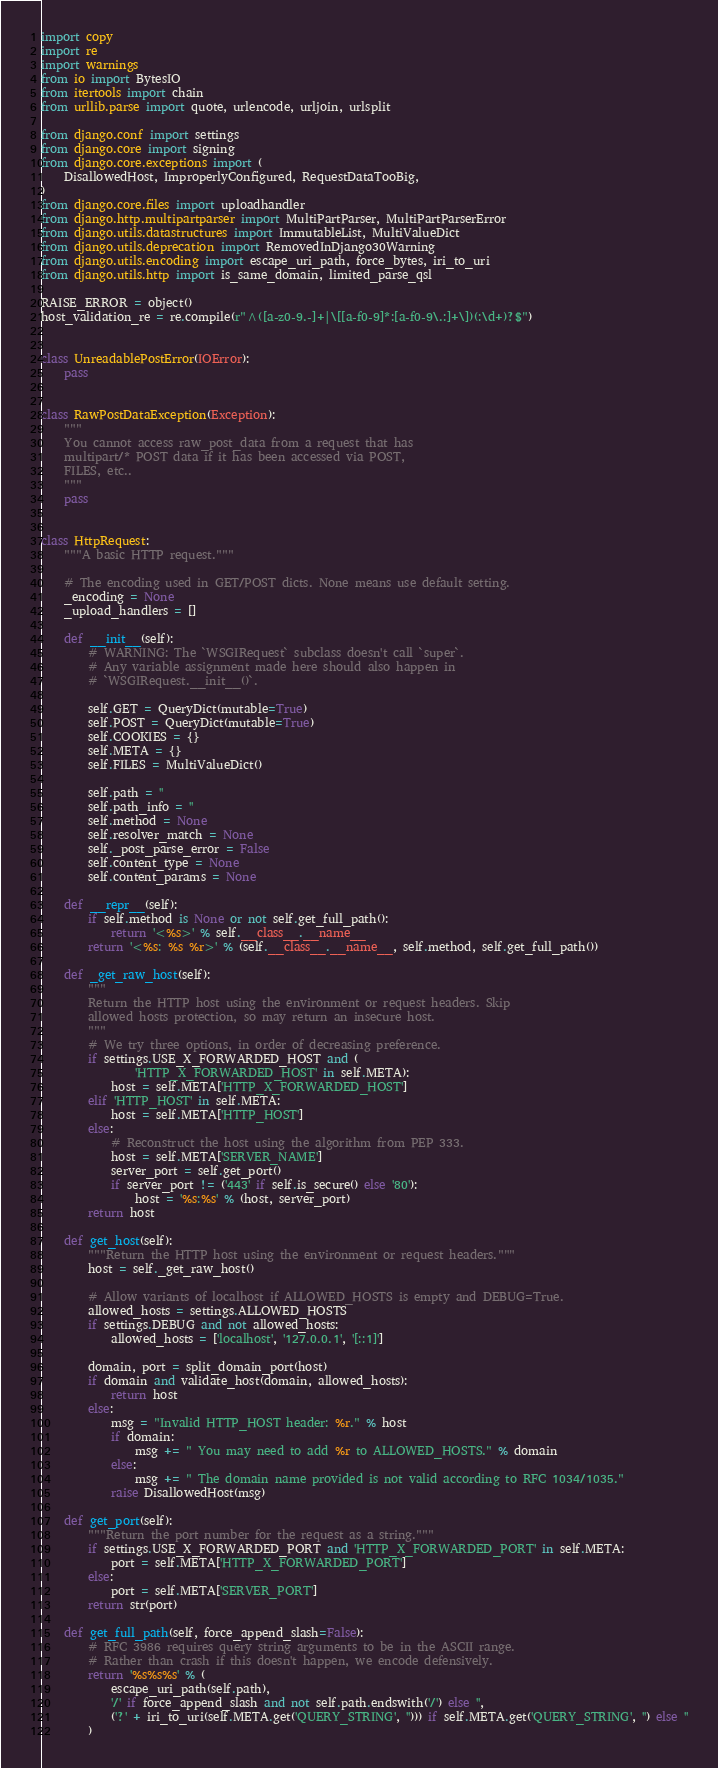<code> <loc_0><loc_0><loc_500><loc_500><_Python_>import copy
import re
import warnings
from io import BytesIO
from itertools import chain
from urllib.parse import quote, urlencode, urljoin, urlsplit

from django.conf import settings
from django.core import signing
from django.core.exceptions import (
    DisallowedHost, ImproperlyConfigured, RequestDataTooBig,
)
from django.core.files import uploadhandler
from django.http.multipartparser import MultiPartParser, MultiPartParserError
from django.utils.datastructures import ImmutableList, MultiValueDict
from django.utils.deprecation import RemovedInDjango30Warning
from django.utils.encoding import escape_uri_path, force_bytes, iri_to_uri
from django.utils.http import is_same_domain, limited_parse_qsl

RAISE_ERROR = object()
host_validation_re = re.compile(r"^([a-z0-9.-]+|\[[a-f0-9]*:[a-f0-9\.:]+\])(:\d+)?$")


class UnreadablePostError(IOError):
    pass


class RawPostDataException(Exception):
    """
    You cannot access raw_post_data from a request that has
    multipart/* POST data if it has been accessed via POST,
    FILES, etc..
    """
    pass


class HttpRequest:
    """A basic HTTP request."""

    # The encoding used in GET/POST dicts. None means use default setting.
    _encoding = None
    _upload_handlers = []

    def __init__(self):
        # WARNING: The `WSGIRequest` subclass doesn't call `super`.
        # Any variable assignment made here should also happen in
        # `WSGIRequest.__init__()`.

        self.GET = QueryDict(mutable=True)
        self.POST = QueryDict(mutable=True)
        self.COOKIES = {}
        self.META = {}
        self.FILES = MultiValueDict()

        self.path = ''
        self.path_info = ''
        self.method = None
        self.resolver_match = None
        self._post_parse_error = False
        self.content_type = None
        self.content_params = None

    def __repr__(self):
        if self.method is None or not self.get_full_path():
            return '<%s>' % self.__class__.__name__
        return '<%s: %s %r>' % (self.__class__.__name__, self.method, self.get_full_path())

    def _get_raw_host(self):
        """
        Return the HTTP host using the environment or request headers. Skip
        allowed hosts protection, so may return an insecure host.
        """
        # We try three options, in order of decreasing preference.
        if settings.USE_X_FORWARDED_HOST and (
                'HTTP_X_FORWARDED_HOST' in self.META):
            host = self.META['HTTP_X_FORWARDED_HOST']
        elif 'HTTP_HOST' in self.META:
            host = self.META['HTTP_HOST']
        else:
            # Reconstruct the host using the algorithm from PEP 333.
            host = self.META['SERVER_NAME']
            server_port = self.get_port()
            if server_port != ('443' if self.is_secure() else '80'):
                host = '%s:%s' % (host, server_port)
        return host

    def get_host(self):
        """Return the HTTP host using the environment or request headers."""
        host = self._get_raw_host()

        # Allow variants of localhost if ALLOWED_HOSTS is empty and DEBUG=True.
        allowed_hosts = settings.ALLOWED_HOSTS
        if settings.DEBUG and not allowed_hosts:
            allowed_hosts = ['localhost', '127.0.0.1', '[::1]']

        domain, port = split_domain_port(host)
        if domain and validate_host(domain, allowed_hosts):
            return host
        else:
            msg = "Invalid HTTP_HOST header: %r." % host
            if domain:
                msg += " You may need to add %r to ALLOWED_HOSTS." % domain
            else:
                msg += " The domain name provided is not valid according to RFC 1034/1035."
            raise DisallowedHost(msg)

    def get_port(self):
        """Return the port number for the request as a string."""
        if settings.USE_X_FORWARDED_PORT and 'HTTP_X_FORWARDED_PORT' in self.META:
            port = self.META['HTTP_X_FORWARDED_PORT']
        else:
            port = self.META['SERVER_PORT']
        return str(port)

    def get_full_path(self, force_append_slash=False):
        # RFC 3986 requires query string arguments to be in the ASCII range.
        # Rather than crash if this doesn't happen, we encode defensively.
        return '%s%s%s' % (
            escape_uri_path(self.path),
            '/' if force_append_slash and not self.path.endswith('/') else '',
            ('?' + iri_to_uri(self.META.get('QUERY_STRING', ''))) if self.META.get('QUERY_STRING', '') else ''
        )
</code> 